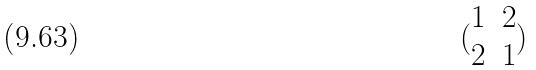<formula> <loc_0><loc_0><loc_500><loc_500>( \begin{matrix} 1 & 2 \\ 2 & 1 \end{matrix} )</formula> 